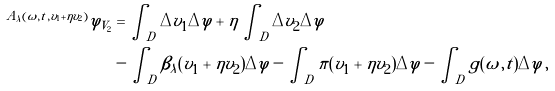Convert formula to latex. <formula><loc_0><loc_0><loc_500><loc_500>^ { A _ { \lambda } ( \omega , t , v _ { 1 } + \eta v _ { 2 } ) } \varphi _ { V _ { 2 } } & = \int _ { D } \Delta v _ { 1 } \Delta \varphi + \eta \int _ { D } \Delta v _ { 2 } \Delta \varphi \\ & - \int _ { D } \beta _ { \lambda } ( v _ { 1 } + \eta v _ { 2 } ) \Delta \varphi - \int _ { D } \pi ( v _ { 1 } + \eta v _ { 2 } ) \Delta \varphi - \int _ { D } g ( \omega , t ) \Delta \varphi \, ,</formula> 